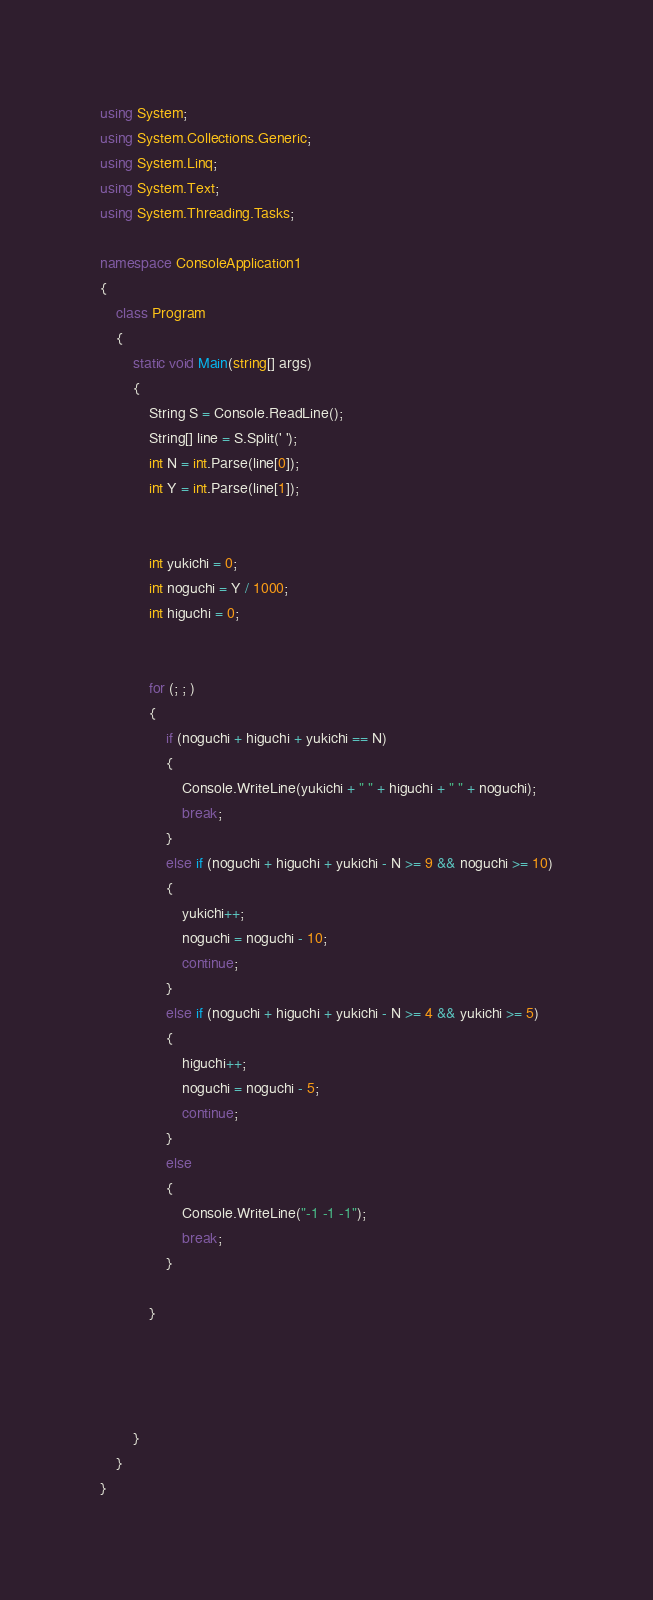<code> <loc_0><loc_0><loc_500><loc_500><_C#_>using System;
using System.Collections.Generic;
using System.Linq;
using System.Text;
using System.Threading.Tasks;

namespace ConsoleApplication1
{
    class Program
    {
        static void Main(string[] args)
        {
            String S = Console.ReadLine();
            String[] line = S.Split(' ');
            int N = int.Parse(line[0]);
            int Y = int.Parse(line[1]);


            int yukichi = 0;
            int noguchi = Y / 1000;
            int higuchi = 0;


            for (; ; )
            {
                if (noguchi + higuchi + yukichi == N)
                {
                    Console.WriteLine(yukichi + " " + higuchi + " " + noguchi);
                    break;
                }
                else if (noguchi + higuchi + yukichi - N >= 9 && noguchi >= 10)
                {
                    yukichi++;
                    noguchi = noguchi - 10;
                    continue;
                }
                else if (noguchi + higuchi + yukichi - N >= 4 && yukichi >= 5)
                {
                    higuchi++;
                    noguchi = noguchi - 5;
                    continue;
                }
                else
                {
                    Console.WriteLine("-1 -1 -1");
                    break;
                }

            }




        }
    }
}
</code> 